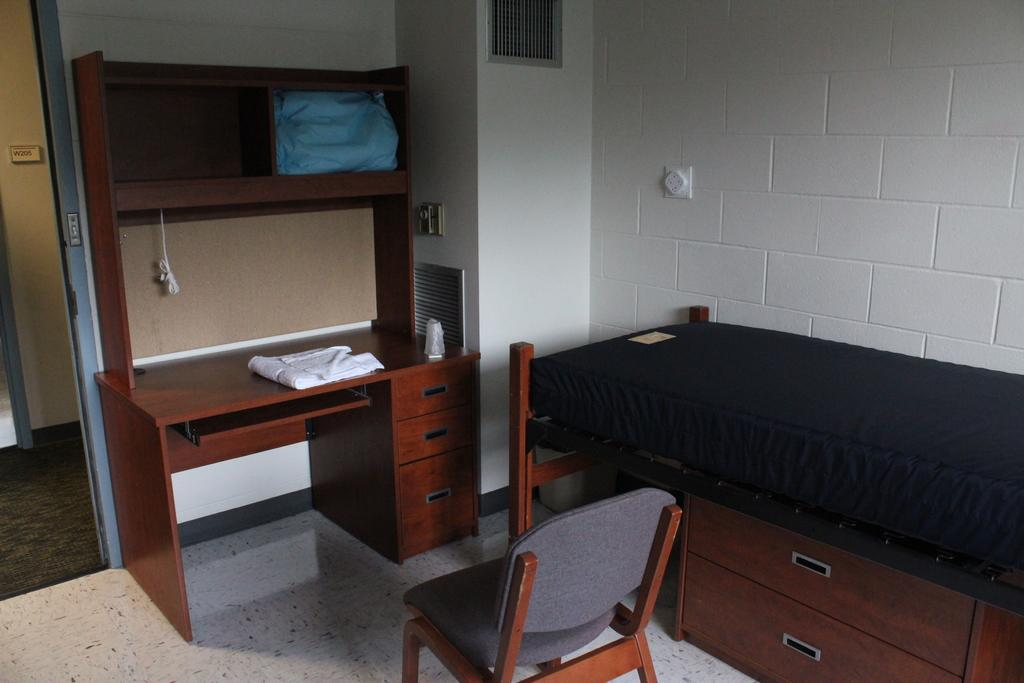What type of furniture is present in the image? There is a bed, a chair, and a television stand in the image. What else can be seen in the image besides furniture? There is a cloth and a wall in the image. Can you describe the wall in the image? There is a wall in the image, but no specific details about its appearance are provided. What type of butter is being spread on the bean in the image? There is no butter or bean present in the image. 